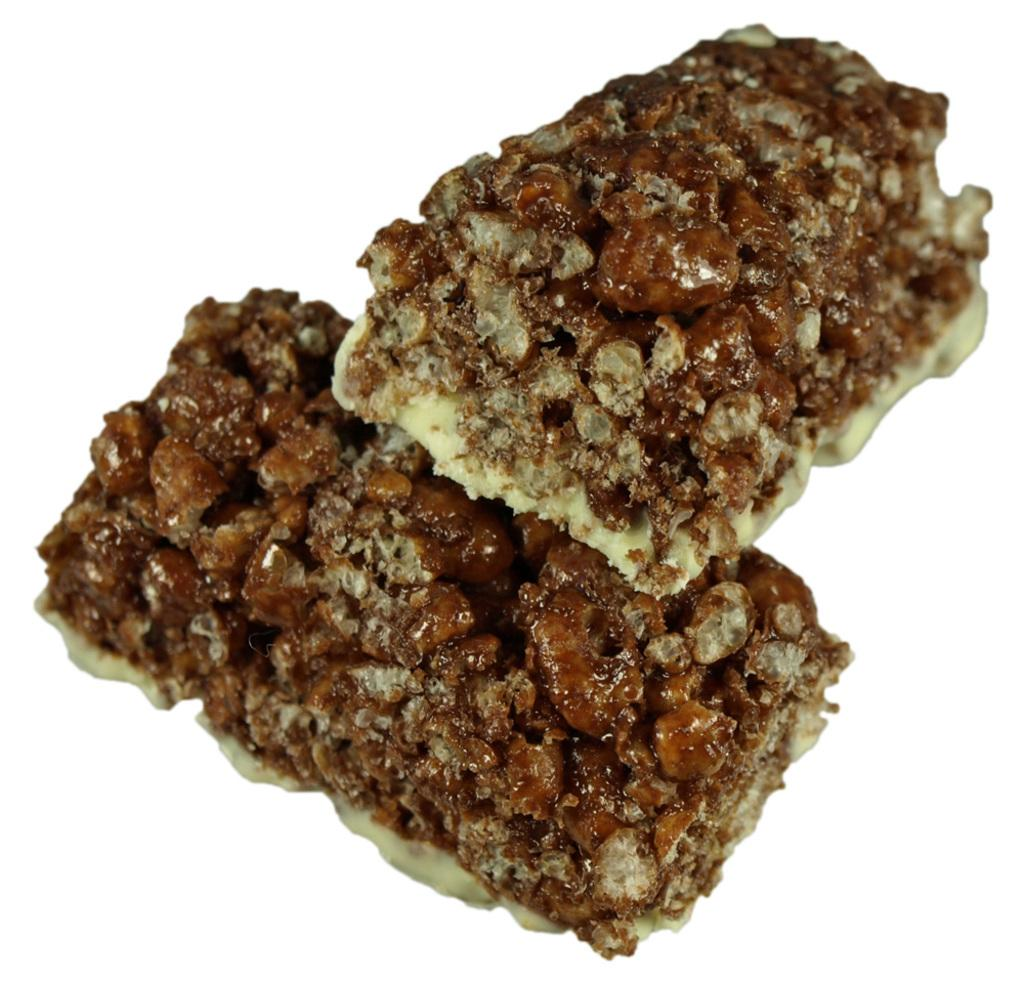What can be seen in the image? There are two pieces of food items in the image. What is the color of the background in the image? The background of the image is white. What type of advice can be seen written on the food items in the image? There is no advice written on the food items in the image. 